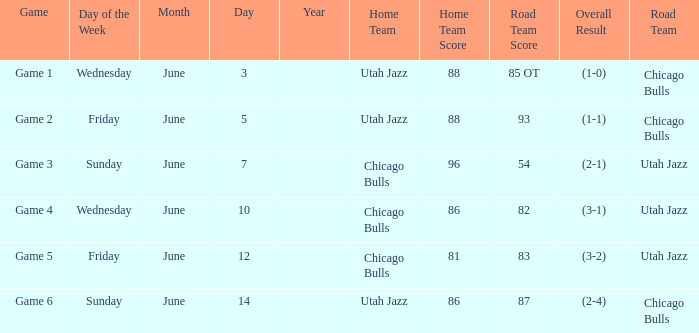Home Team of chicago bulls, and a Result of 81-83 (3-2) involved what game? Game 5. Could you parse the entire table as a dict? {'header': ['Game', 'Day of the Week', 'Month', 'Day', 'Year', 'Home Team', 'Home Team Score', 'Road Team Score', 'Overall Result', 'Road Team'], 'rows': [['Game 1', 'Wednesday', 'June', '3', '', 'Utah Jazz', '88', '85 OT', '(1-0)', 'Chicago Bulls'], ['Game 2', 'Friday', 'June', '5', '', 'Utah Jazz', '88', '93', '(1-1)', 'Chicago Bulls'], ['Game 3', 'Sunday', 'June', '7', '', 'Chicago Bulls', '96', '54', '(2-1)', 'Utah Jazz'], ['Game 4', 'Wednesday', 'June', '10', '', 'Chicago Bulls', '86', '82', '(3-1)', 'Utah Jazz'], ['Game 5', 'Friday', 'June', '12', '', 'Chicago Bulls', '81', '83', '(3-2)', 'Utah Jazz'], ['Game 6', 'Sunday', 'June', '14', '', 'Utah Jazz', '86', '87', '(2-4)', 'Chicago Bulls']]} 